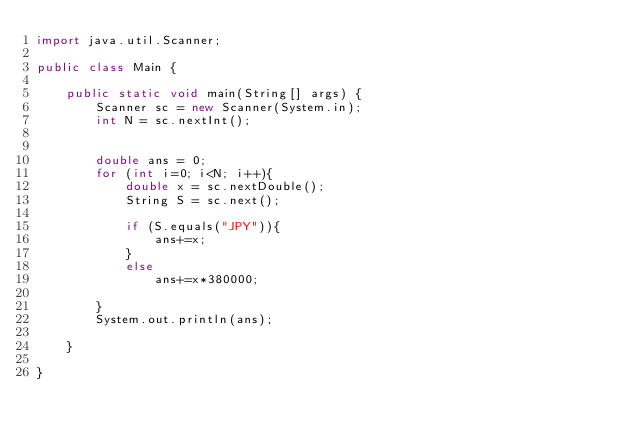<code> <loc_0><loc_0><loc_500><loc_500><_Java_>import java.util.Scanner;

public class Main {

	public static void main(String[] args) {
		Scanner sc = new Scanner(System.in);
		int N = sc.nextInt();
		
		
		double ans = 0;
		for (int i=0; i<N; i++){
			double x = sc.nextDouble();
			String S = sc.next();
			
			if (S.equals("JPY")){
				ans+=x;
			}
			else 
				ans+=x*380000;
			
		}
		System.out.println(ans);

	}

}
</code> 